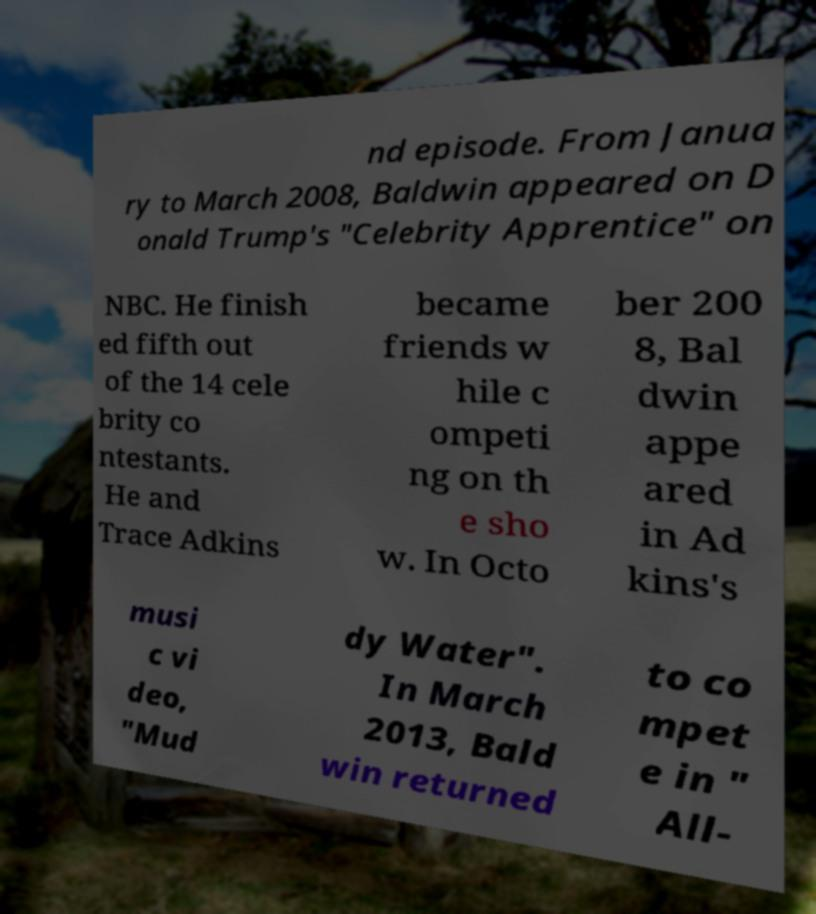Could you extract and type out the text from this image? nd episode. From Janua ry to March 2008, Baldwin appeared on D onald Trump's "Celebrity Apprentice" on NBC. He finish ed fifth out of the 14 cele brity co ntestants. He and Trace Adkins became friends w hile c ompeti ng on th e sho w. In Octo ber 200 8, Bal dwin appe ared in Ad kins's musi c vi deo, "Mud dy Water". In March 2013, Bald win returned to co mpet e in " All- 